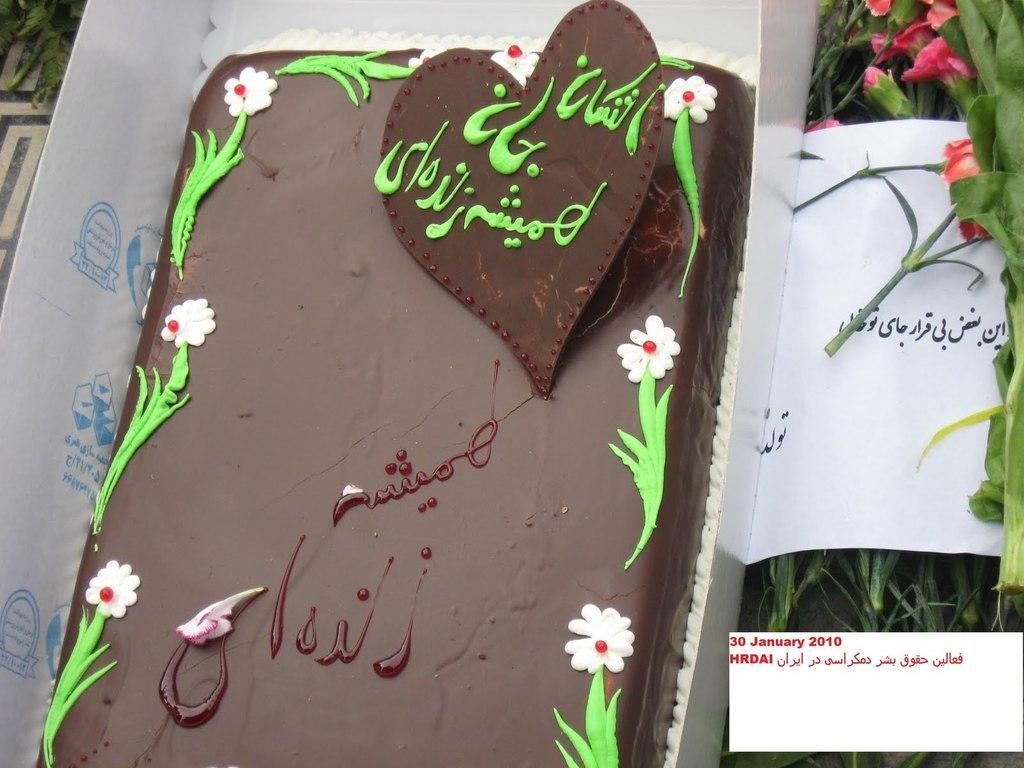In one or two sentences, can you explain what this image depicts? This picture contains a cake which is placed in pastry box. Beside that, we see a paper which some text written in Urdu language. We even see flowers and plants. 